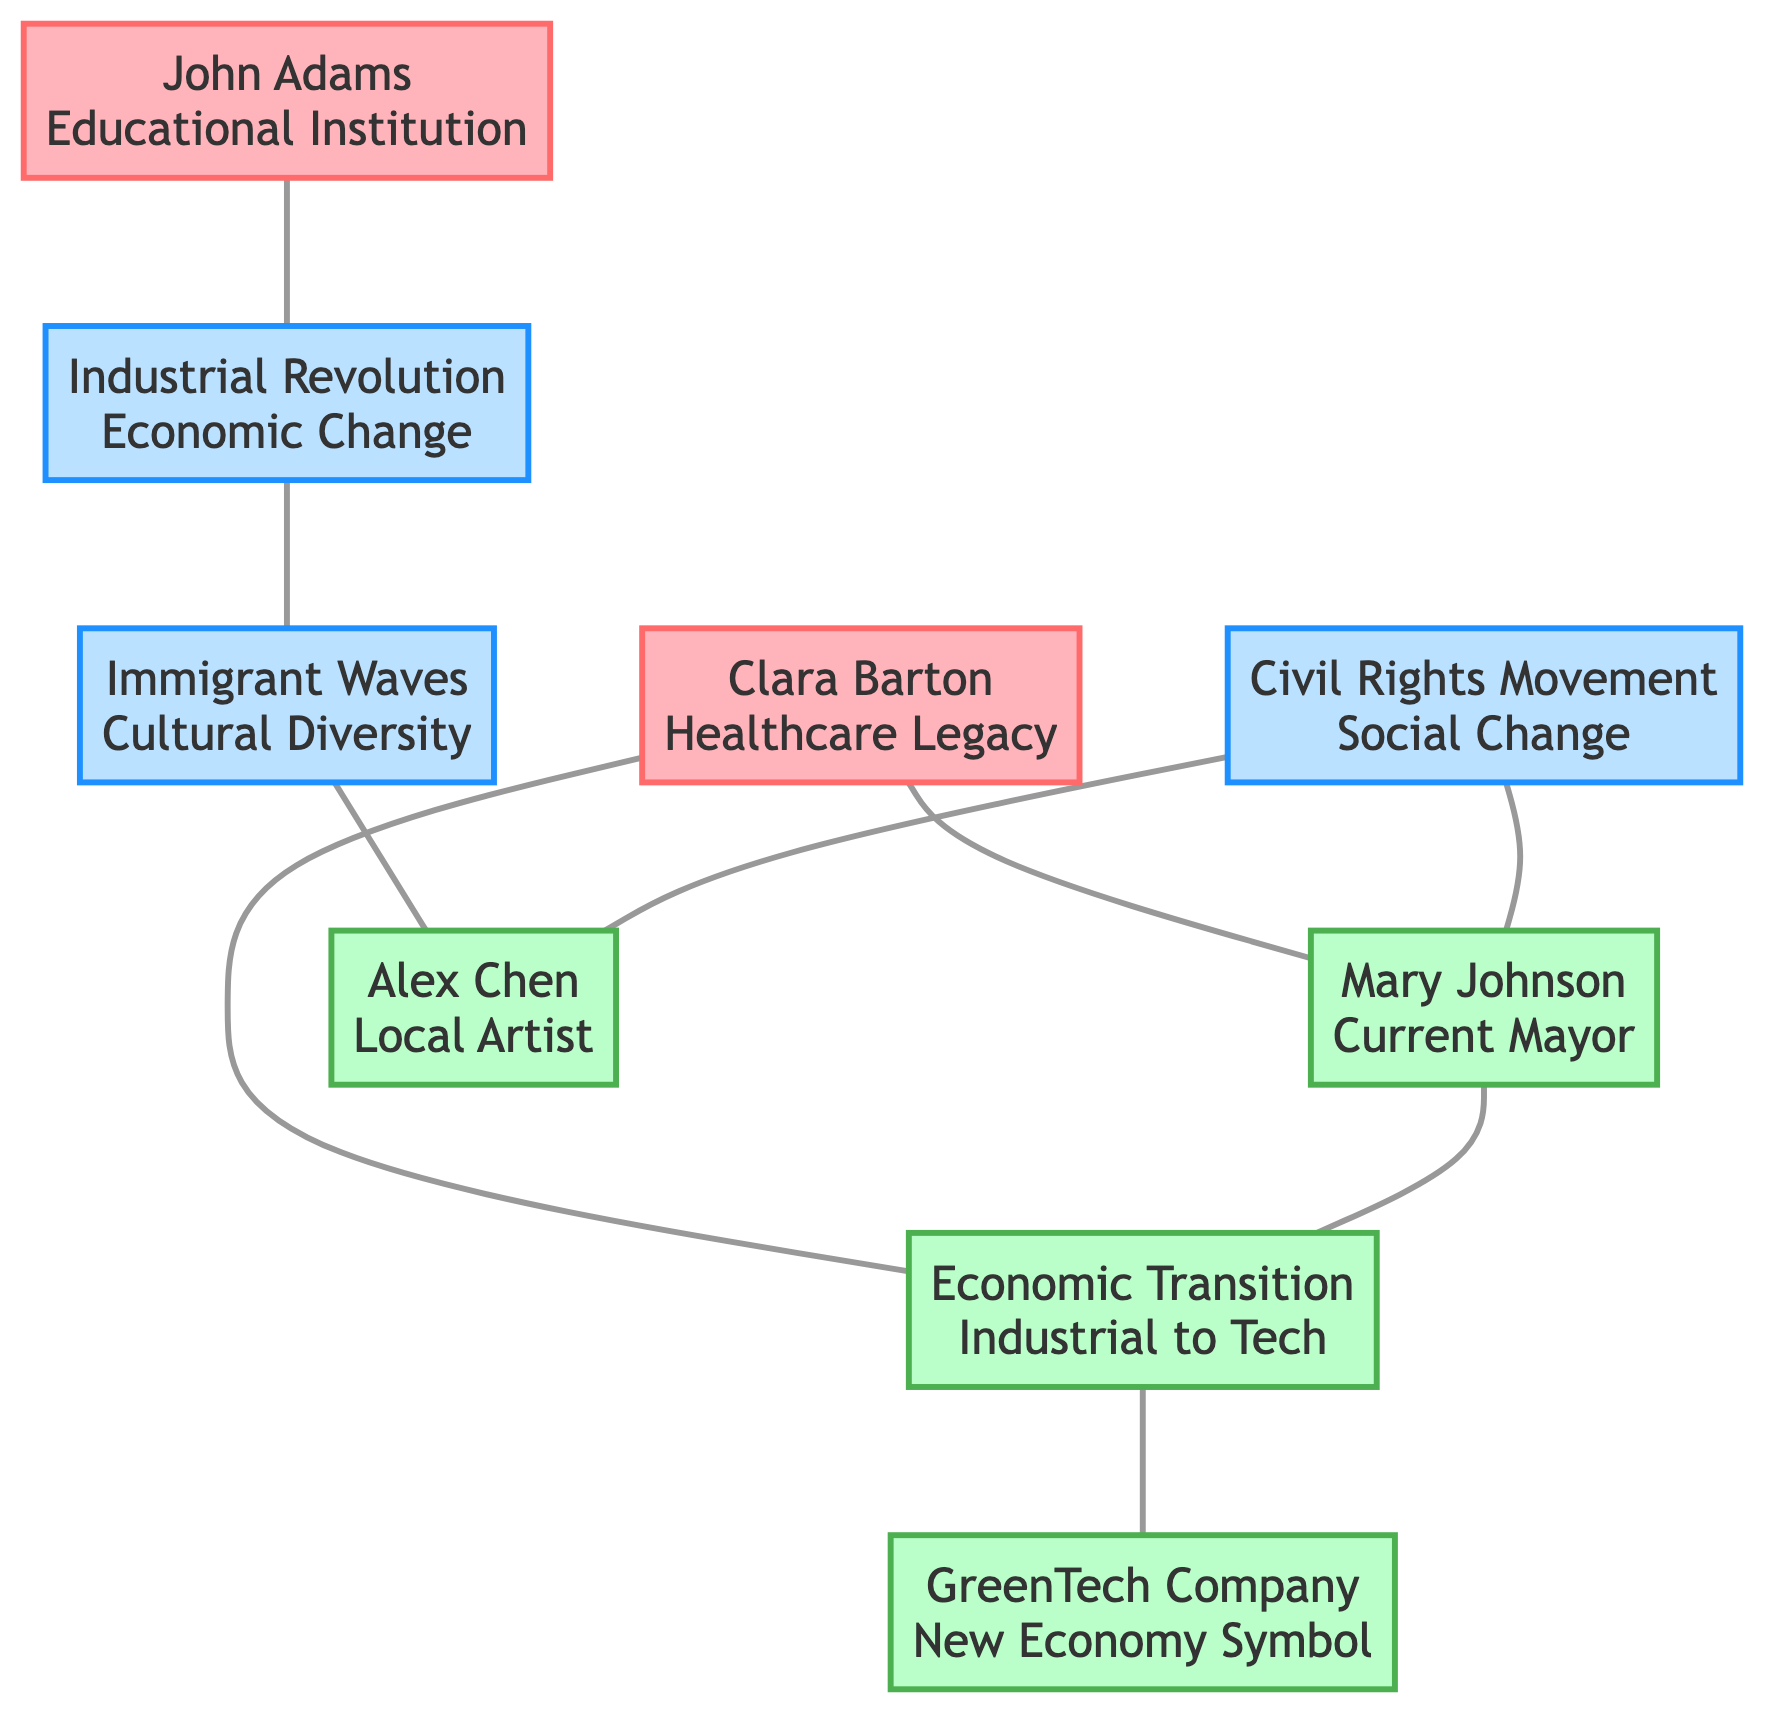What historical figure established the town's first educational institution? The diagram shows that the node "Historical Figure: John Adams" is directly connected to "Historical Event: Industrial Revolution," indicating that he is the figure associated with the establishment of education in the town.
Answer: John Adams What modern issue is influenced by Clara Barton? The diagram links "Historical Figure: Clara Barton" to "Modern Issue: Economic Transition," suggesting that her legacy has an impact on current economic challenges faced by the town.
Answer: Economic Transition How many cultural influences are represented in the diagram? Upon reviewing the nodes, there is one node labeled "Cultural Influence: Immigrant Waves," indicating that only one cultural influence is explicitly shown in the diagram.
Answer: 1 Which modern character's work is inspired by immigrant waves? The connection between "Cultural Influence: Immigrant Waves" and "Modern Character: Alex Chen" shows that Alex Chen draws artistic inspiration from the immigrant cultures represented in the town.
Answer: Alex Chen What role does Mary Johnson play in the context of the Civil Rights Movement? The diagram shows connections between "Historical Event: Civil Rights Movement" and "Modern Character: Mary Johnson," specifically mentioning "Equality in governance," indicating her role relates to promoting equality.
Answer: Current Mayor Which event attracted a labor force to the town? The link from "Historical Event: Industrial Revolution" to "Cultural Influence: Immigrant Waves" indicates that the Industrial Revolution brought in a workforce, thereby attracting labor to the town.
Answer: Industrial Revolution What institution symbolizes the town's shift from industrial roots? The node "Modern Institution: GreenTech Company" is linked to "Modern Issue: Economic Transition," representing a new technological focus as the town transitions from its industrial background.
Answer: GreenTech Company Which historical figure influenced healthcare advocacy in the town? The diagram shows a direct connection from "Historical Figure: Clara Barton" to "Modern Character: Mary Johnson," specifically citing "Healthcare advocacy influence," indicating Clara Barton's impact in this area.
Answer: Clara Barton What is a modern character's policy focus related to economic transition? The node "Modern Character: Mary Johnson" is connected to "Modern Issue: Economic Transition" with the relationship "Policy development," which highlights her role in developing policies addressing current economic shifts.
Answer: Policy development 